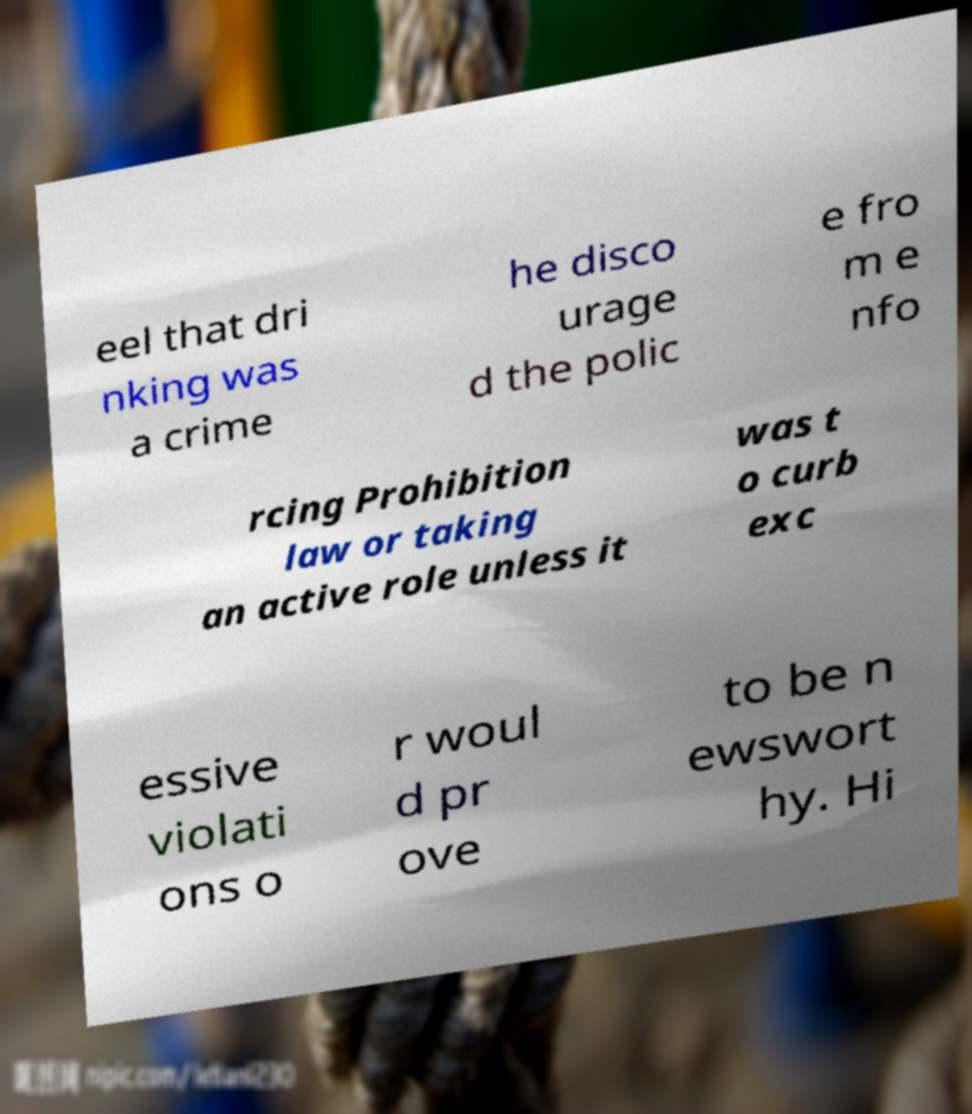For documentation purposes, I need the text within this image transcribed. Could you provide that? eel that dri nking was a crime he disco urage d the polic e fro m e nfo rcing Prohibition law or taking an active role unless it was t o curb exc essive violati ons o r woul d pr ove to be n ewswort hy. Hi 